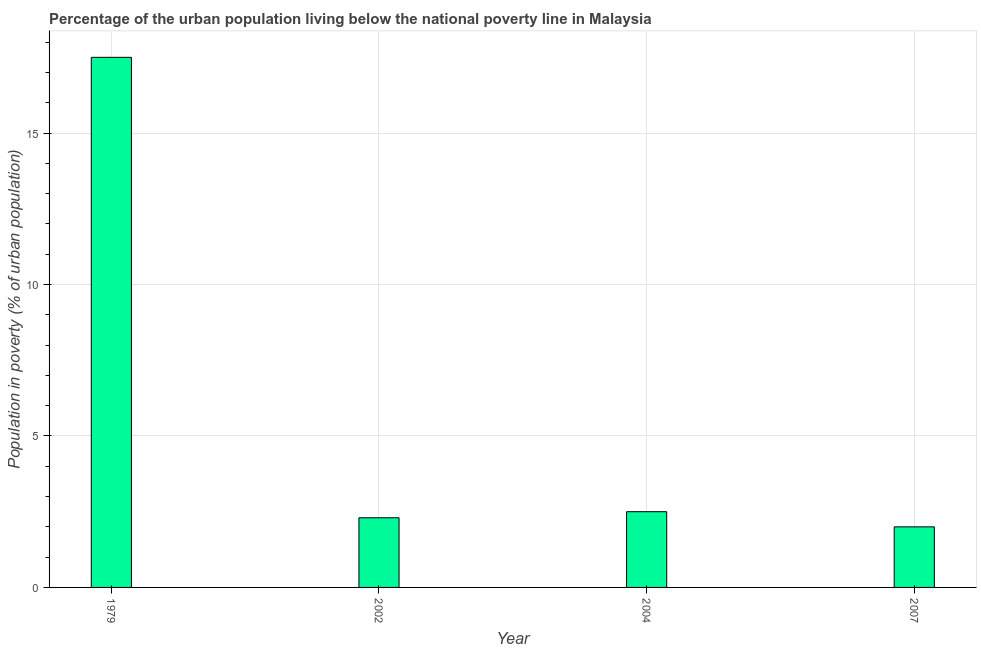Does the graph contain grids?
Offer a very short reply. Yes. What is the title of the graph?
Ensure brevity in your answer.  Percentage of the urban population living below the national poverty line in Malaysia. What is the label or title of the X-axis?
Ensure brevity in your answer.  Year. What is the label or title of the Y-axis?
Keep it short and to the point. Population in poverty (% of urban population). What is the percentage of urban population living below poverty line in 2007?
Ensure brevity in your answer.  2. Across all years, what is the minimum percentage of urban population living below poverty line?
Your response must be concise. 2. In which year was the percentage of urban population living below poverty line maximum?
Keep it short and to the point. 1979. What is the sum of the percentage of urban population living below poverty line?
Offer a terse response. 24.3. What is the difference between the percentage of urban population living below poverty line in 2002 and 2007?
Your response must be concise. 0.3. What is the average percentage of urban population living below poverty line per year?
Give a very brief answer. 6.08. Do a majority of the years between 2004 and 1979 (inclusive) have percentage of urban population living below poverty line greater than 17 %?
Your response must be concise. Yes. What is the ratio of the percentage of urban population living below poverty line in 2004 to that in 2007?
Make the answer very short. 1.25. What is the difference between the highest and the second highest percentage of urban population living below poverty line?
Make the answer very short. 15. Is the sum of the percentage of urban population living below poverty line in 2004 and 2007 greater than the maximum percentage of urban population living below poverty line across all years?
Provide a short and direct response. No. How many bars are there?
Keep it short and to the point. 4. Are all the bars in the graph horizontal?
Your response must be concise. No. Are the values on the major ticks of Y-axis written in scientific E-notation?
Make the answer very short. No. What is the Population in poverty (% of urban population) of 1979?
Give a very brief answer. 17.5. What is the Population in poverty (% of urban population) in 2002?
Your answer should be very brief. 2.3. What is the Population in poverty (% of urban population) of 2004?
Offer a terse response. 2.5. What is the difference between the Population in poverty (% of urban population) in 1979 and 2004?
Your answer should be compact. 15. What is the difference between the Population in poverty (% of urban population) in 1979 and 2007?
Your answer should be compact. 15.5. What is the ratio of the Population in poverty (% of urban population) in 1979 to that in 2002?
Offer a terse response. 7.61. What is the ratio of the Population in poverty (% of urban population) in 1979 to that in 2004?
Your answer should be very brief. 7. What is the ratio of the Population in poverty (% of urban population) in 1979 to that in 2007?
Provide a succinct answer. 8.75. What is the ratio of the Population in poverty (% of urban population) in 2002 to that in 2007?
Offer a very short reply. 1.15. 